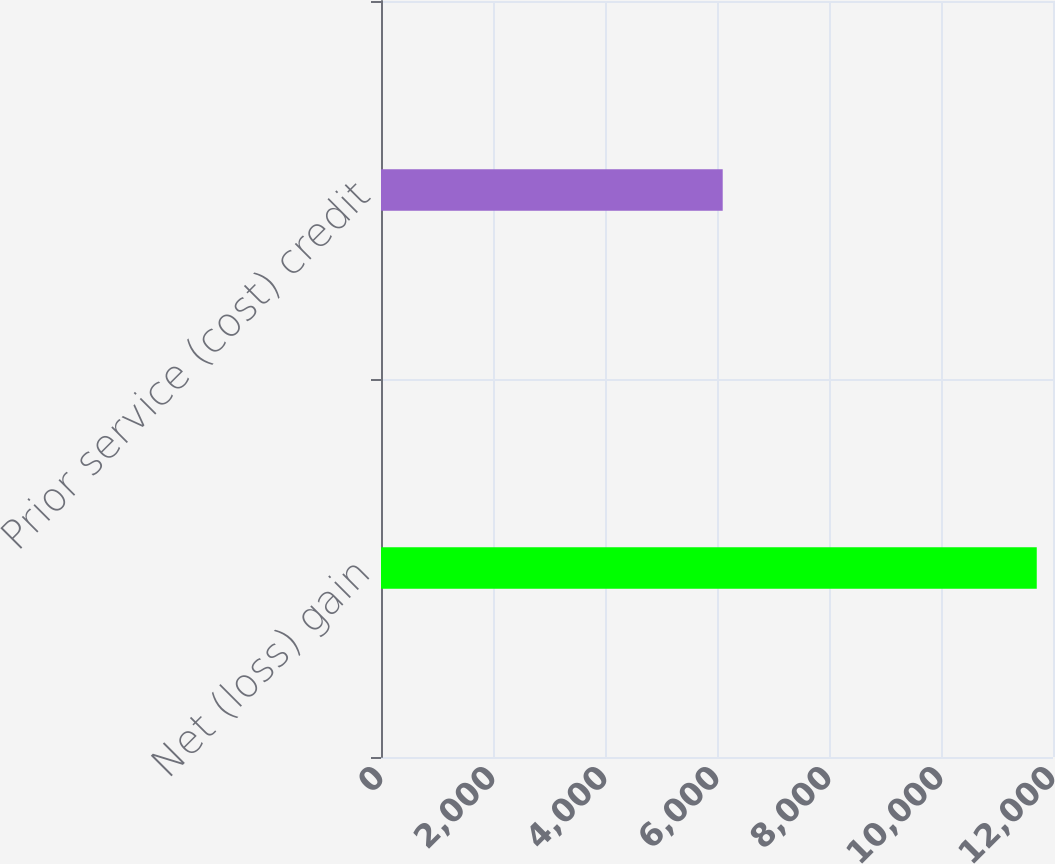<chart> <loc_0><loc_0><loc_500><loc_500><bar_chart><fcel>Net (loss) gain<fcel>Prior service (cost) credit<nl><fcel>11710<fcel>6102<nl></chart> 